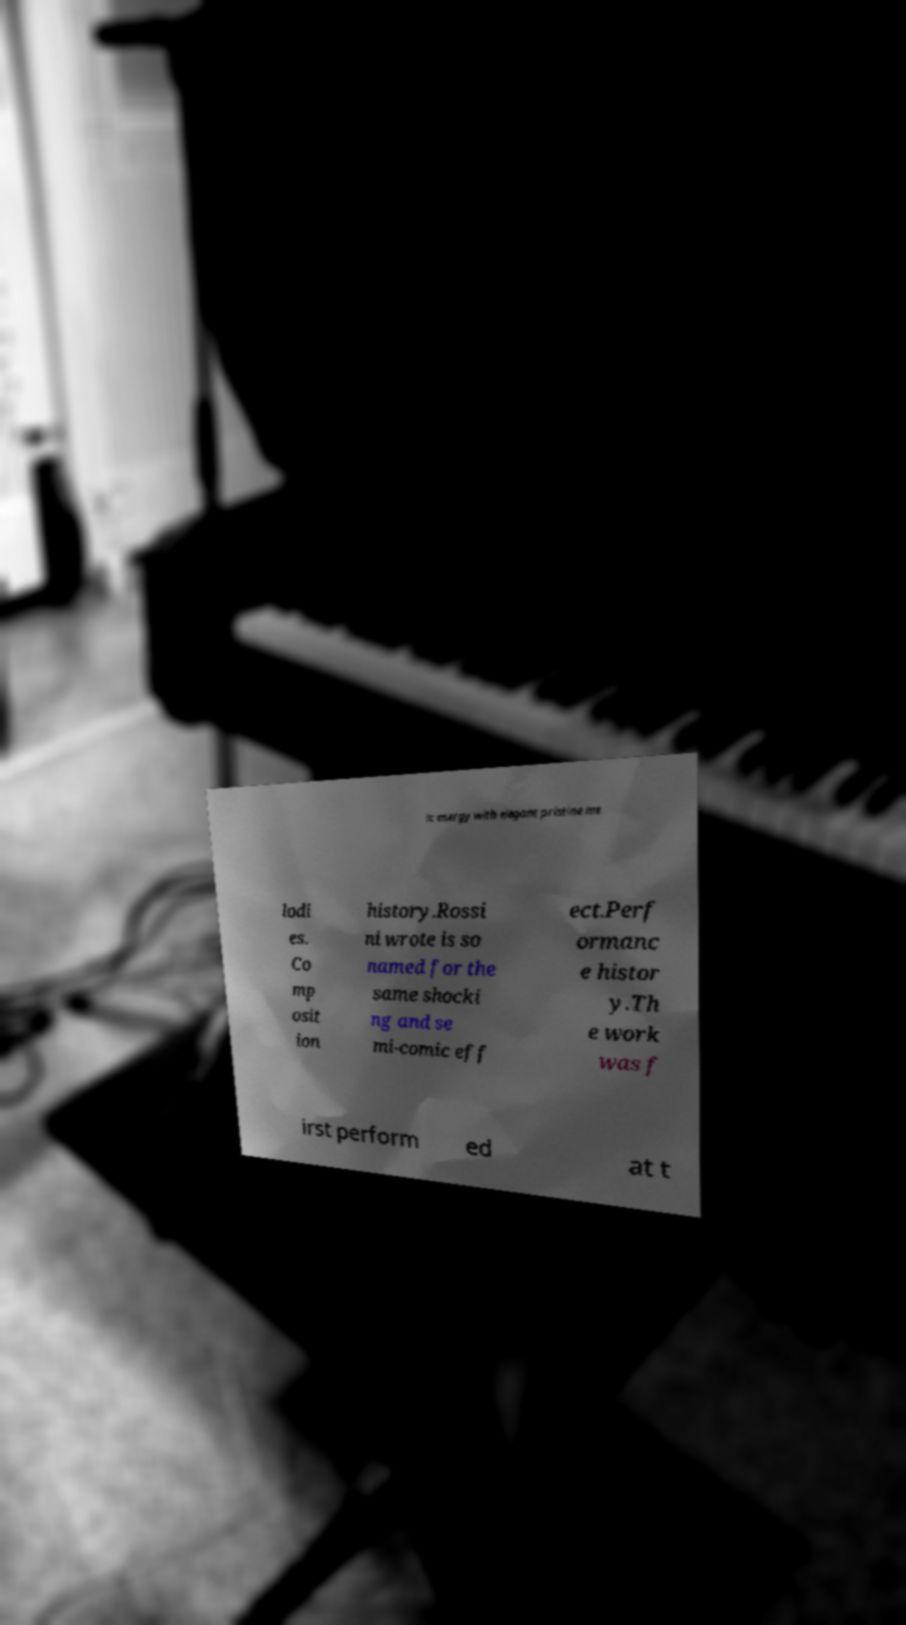Could you extract and type out the text from this image? ic energy with elegant pristine me lodi es. Co mp osit ion history.Rossi ni wrote is so named for the same shocki ng and se mi-comic eff ect.Perf ormanc e histor y.Th e work was f irst perform ed at t 